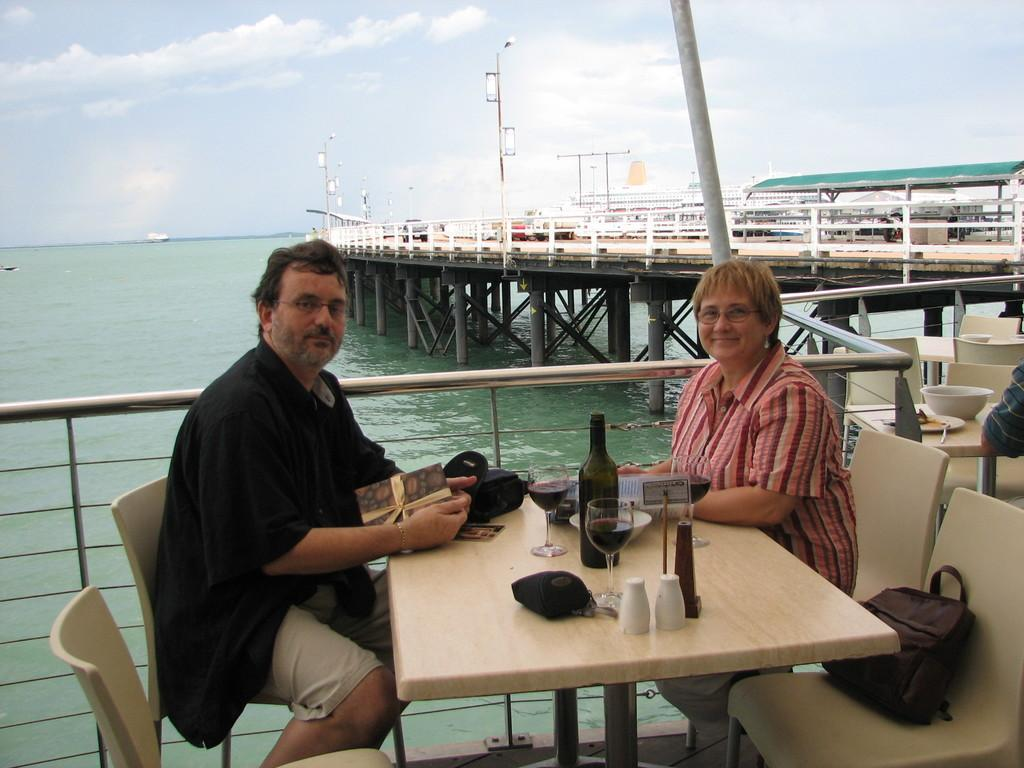How many people are sitting in the image? There are two people sitting on chairs in the image. What is on one of the chairs? There is a bag on one of the chairs. What is present in the image besides the people and chairs? There is a table, a glass, a bottle, another bag, a greeting, and water visible at the back side of the image. What type of dirt can be seen on the patch of the uncle's shirt in the image? There is no uncle or patch of dirt visible on a shirt in the image. 